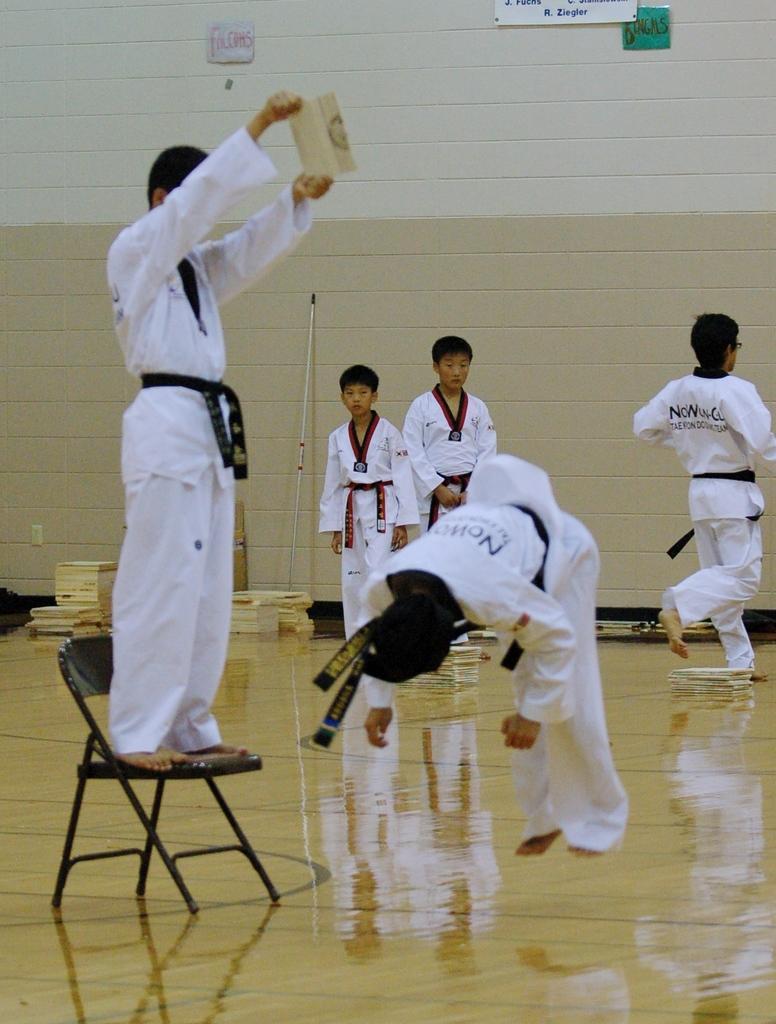Can you describe this image briefly? In the center of the image there is a jumping. On the left side of the image we can see person standing on the chair. In the background there are persons and wall. 